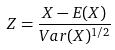<formula> <loc_0><loc_0><loc_500><loc_500>Z = \frac { X - E ( X ) } { V a r ( X ) ^ { 1 / 2 } }</formula> 